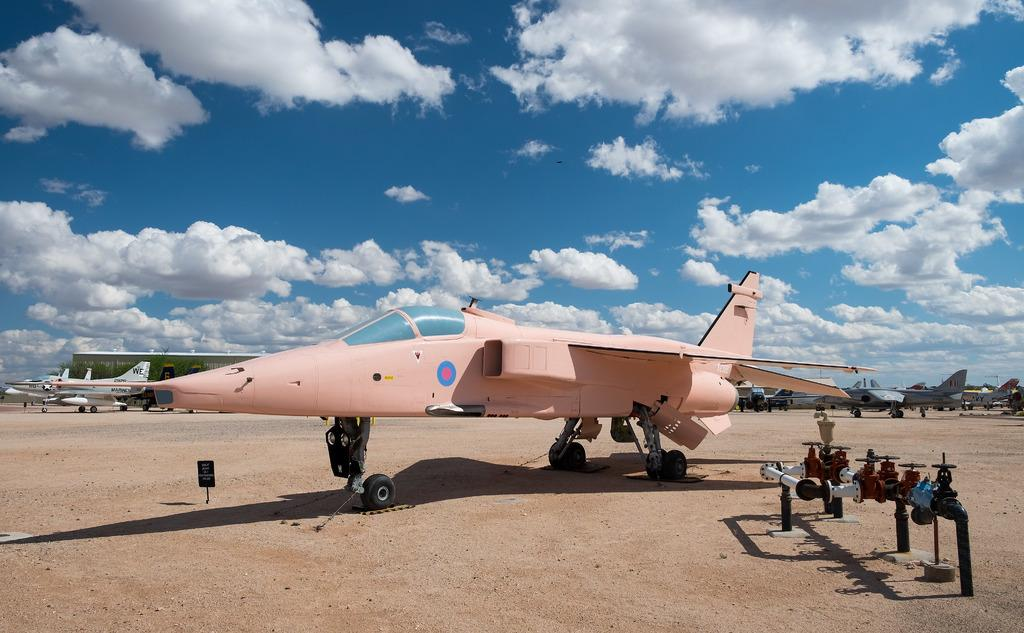What type of vehicles are on the ground in the image? There are airplanes on the ground in the image. What other objects can be seen on the ground in the image? Pipes are visible in the image. What is the rectangular object in the image? There is a board in the image. What is visible in the background of the image? The sky is visible in the background of the image. What can be seen in the sky in the image? Clouds are present in the sky. What type of key is used to unlock the airplane in the image? There is no key present in the image, and no indication that the airplanes need to be unlocked. 